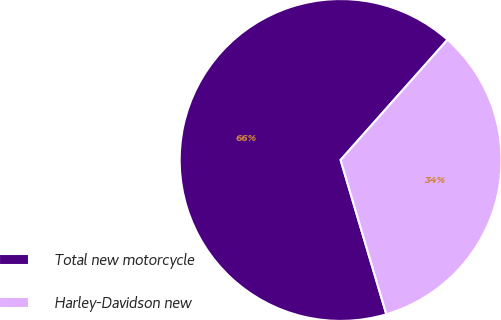Convert chart to OTSL. <chart><loc_0><loc_0><loc_500><loc_500><pie_chart><fcel>Total new motorcycle<fcel>Harley-Davidson new<nl><fcel>66.15%<fcel>33.85%<nl></chart> 